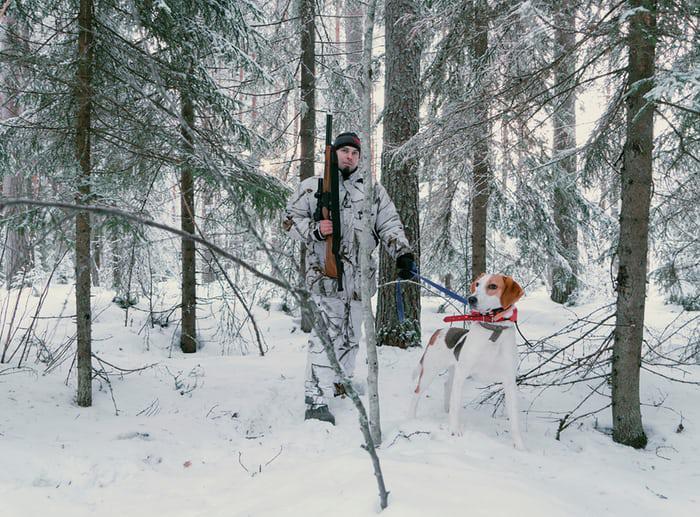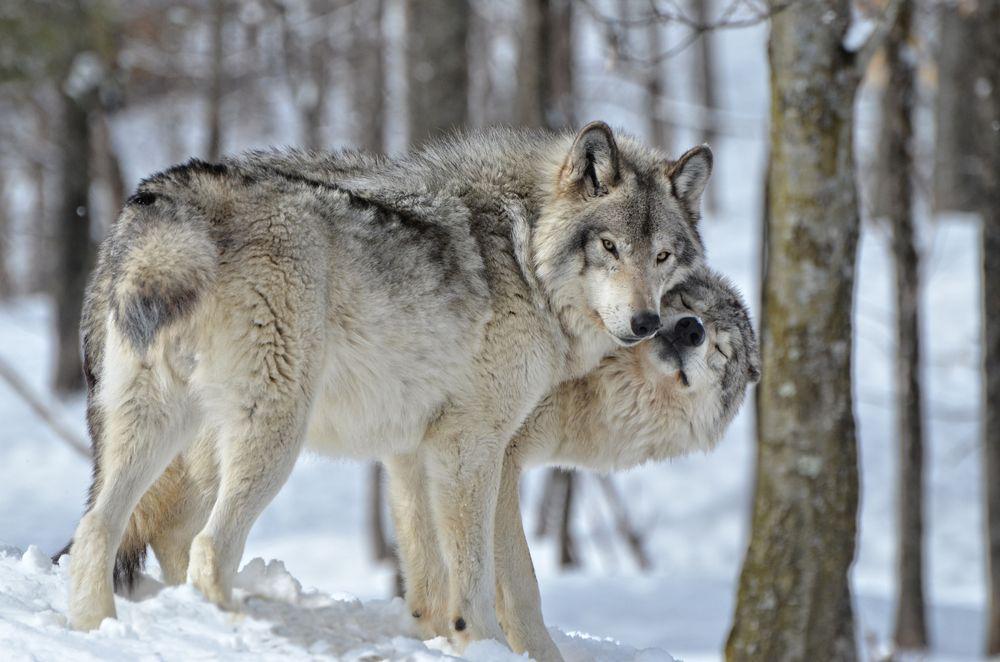The first image is the image on the left, the second image is the image on the right. For the images shown, is this caption "An image shows only two wolves in a snowy scene." true? Answer yes or no. Yes. The first image is the image on the left, the second image is the image on the right. Evaluate the accuracy of this statement regarding the images: "One image in the set contains exactly 3 wolves, in a snowy setting with at least one tree in the background.". Is it true? Answer yes or no. No. 